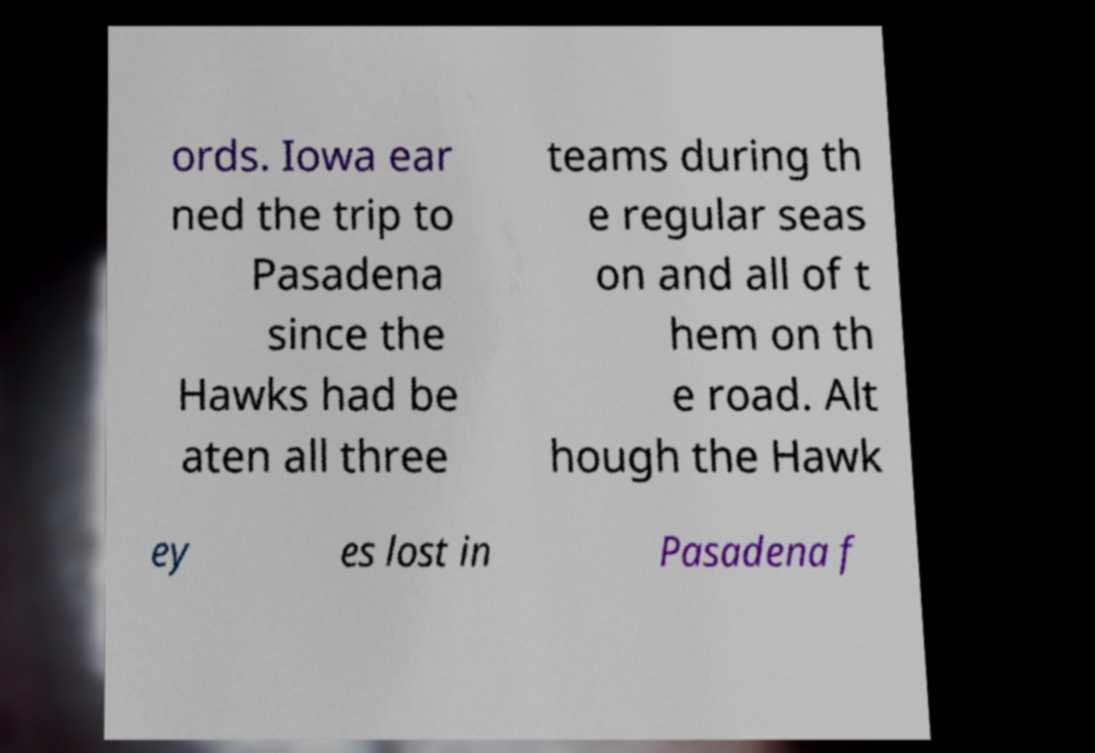Please identify and transcribe the text found in this image. ords. Iowa ear ned the trip to Pasadena since the Hawks had be aten all three teams during th e regular seas on and all of t hem on th e road. Alt hough the Hawk ey es lost in Pasadena f 